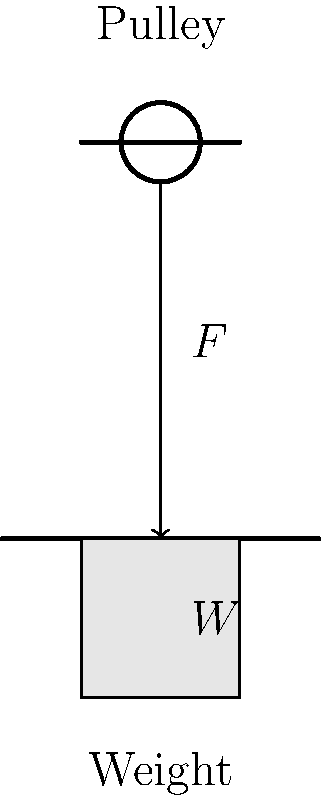During a military equipment recovery operation, you need to lift a 500 kg crate using a pulley system. The system consists of a single fixed pulley. Assuming ideal conditions with no friction, what force $F$ is required to lift the crate? (Use $g = 9.8$ m/s²) To solve this problem, we'll follow these steps:

1) First, recall that the weight of an object is given by $W = mg$, where $m$ is the mass and $g$ is the acceleration due to gravity.

2) Calculate the weight of the crate:
   $W = 500 \text{ kg} \times 9.8 \text{ m/s²} = 4900 \text{ N}$

3) In an ideal single fixed pulley system, the force required to lift an object is equal to the weight of the object. This is because the pulley only changes the direction of the force, not its magnitude.

4) Therefore, the force $F$ required to lift the crate is equal to the weight of the crate:
   $F = W = 4900 \text{ N}$

5) This force of 4900 N is equivalent to about 1102 pounds-force, which is a significant weight that would typically require mechanical assistance in a military context.
Answer: $F = 4900 \text{ N}$ 